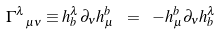<formula> <loc_0><loc_0><loc_500><loc_500>\Gamma _ { \ \mu \nu } ^ { \lambda } \equiv h _ { b } ^ { \lambda } \partial _ { \nu } h _ { \mu } ^ { b } \ = \ - h _ { \mu } ^ { b } \partial _ { \nu } h _ { b } ^ { \lambda }</formula> 